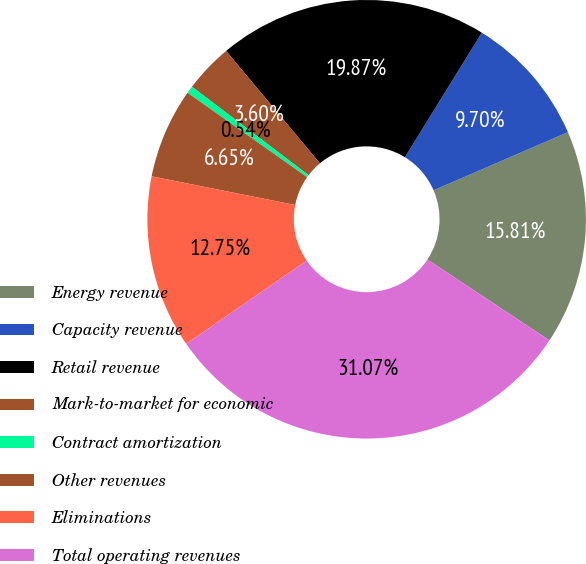Convert chart to OTSL. <chart><loc_0><loc_0><loc_500><loc_500><pie_chart><fcel>Energy revenue<fcel>Capacity revenue<fcel>Retail revenue<fcel>Mark-to-market for economic<fcel>Contract amortization<fcel>Other revenues<fcel>Eliminations<fcel>Total operating revenues<nl><fcel>15.81%<fcel>9.7%<fcel>19.87%<fcel>3.6%<fcel>0.54%<fcel>6.65%<fcel>12.75%<fcel>31.07%<nl></chart> 